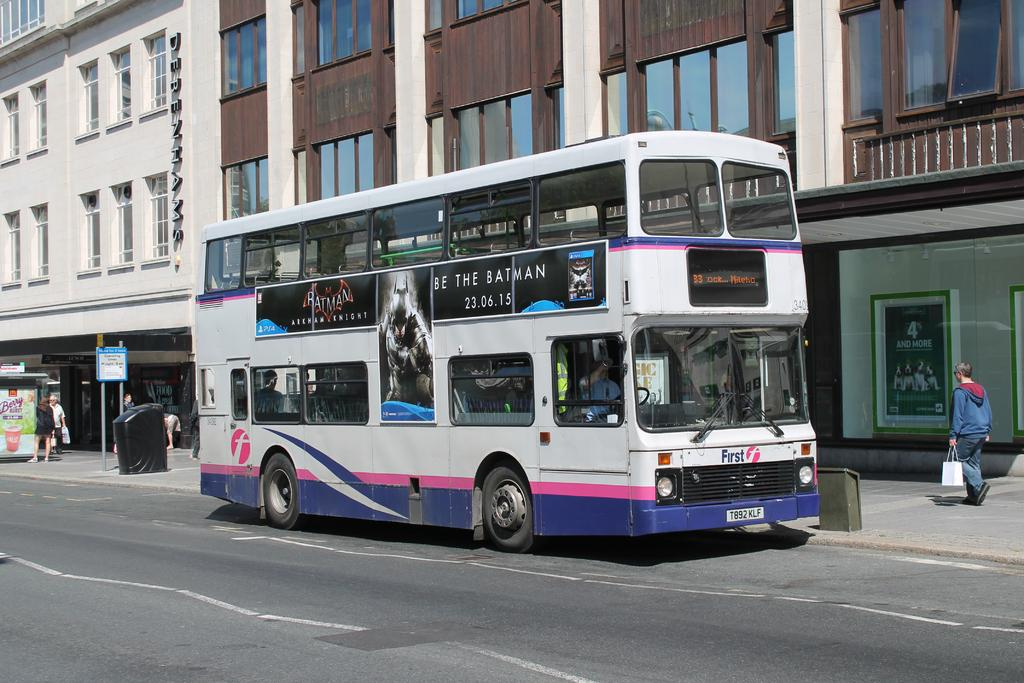Provide a one-sentence caption for the provided image. A double decker bus with an ad for Batman on the side and the quote, "Be the Batman.". 